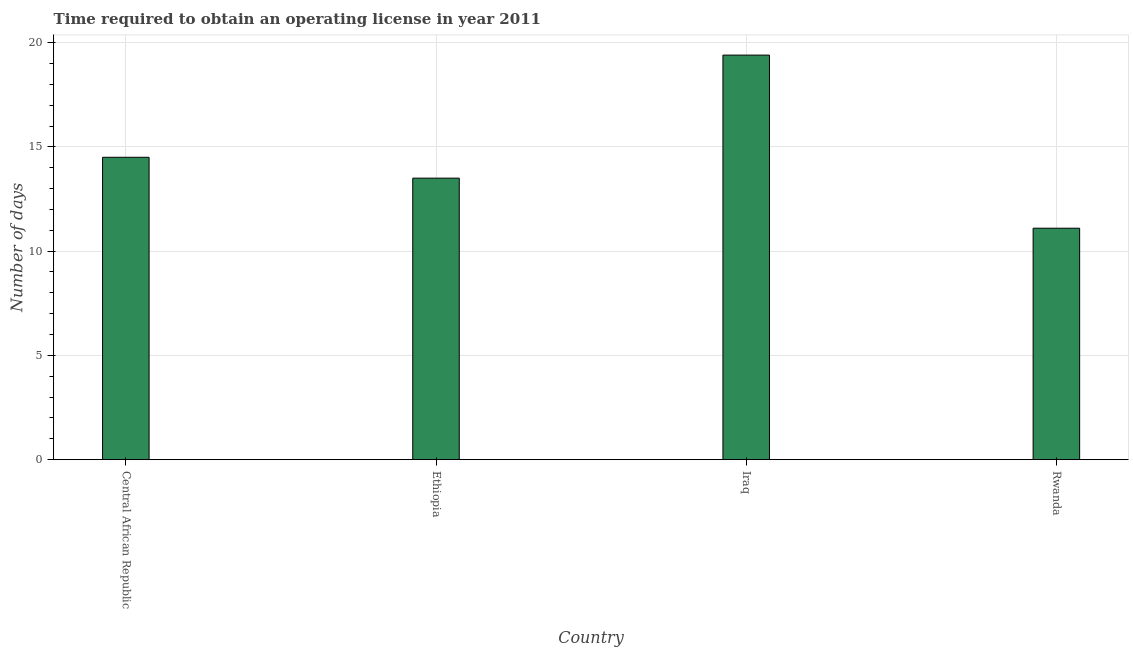Does the graph contain grids?
Your answer should be compact. Yes. What is the title of the graph?
Ensure brevity in your answer.  Time required to obtain an operating license in year 2011. What is the label or title of the X-axis?
Make the answer very short. Country. What is the label or title of the Y-axis?
Ensure brevity in your answer.  Number of days. In which country was the number of days to obtain operating license maximum?
Make the answer very short. Iraq. In which country was the number of days to obtain operating license minimum?
Provide a short and direct response. Rwanda. What is the sum of the number of days to obtain operating license?
Make the answer very short. 58.5. What is the average number of days to obtain operating license per country?
Provide a succinct answer. 14.62. What is the median number of days to obtain operating license?
Your response must be concise. 14. What is the ratio of the number of days to obtain operating license in Iraq to that in Rwanda?
Give a very brief answer. 1.75. Is the number of days to obtain operating license in Central African Republic less than that in Iraq?
Provide a short and direct response. Yes. What is the difference between the highest and the second highest number of days to obtain operating license?
Your answer should be very brief. 4.9. Is the sum of the number of days to obtain operating license in Ethiopia and Iraq greater than the maximum number of days to obtain operating license across all countries?
Offer a very short reply. Yes. In how many countries, is the number of days to obtain operating license greater than the average number of days to obtain operating license taken over all countries?
Give a very brief answer. 1. Are the values on the major ticks of Y-axis written in scientific E-notation?
Offer a terse response. No. What is the Number of days in Ethiopia?
Ensure brevity in your answer.  13.5. What is the Number of days of Rwanda?
Your answer should be compact. 11.1. What is the difference between the Number of days in Central African Republic and Iraq?
Your answer should be compact. -4.9. What is the difference between the Number of days in Central African Republic and Rwanda?
Make the answer very short. 3.4. What is the ratio of the Number of days in Central African Republic to that in Ethiopia?
Provide a succinct answer. 1.07. What is the ratio of the Number of days in Central African Republic to that in Iraq?
Your answer should be compact. 0.75. What is the ratio of the Number of days in Central African Republic to that in Rwanda?
Offer a very short reply. 1.31. What is the ratio of the Number of days in Ethiopia to that in Iraq?
Provide a short and direct response. 0.7. What is the ratio of the Number of days in Ethiopia to that in Rwanda?
Your answer should be compact. 1.22. What is the ratio of the Number of days in Iraq to that in Rwanda?
Offer a very short reply. 1.75. 